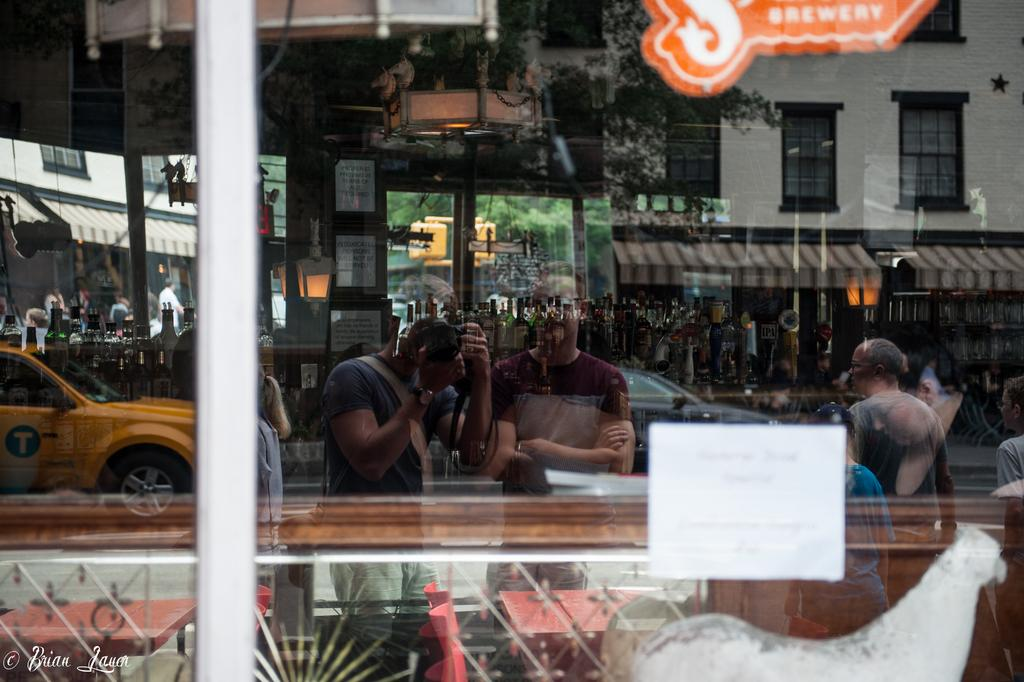What object is present in the image that has a glass component? The image contains a glass. What can be seen through the glass? Vehicles, persons, frames, trees, and buildings are visible through the glass. Can you tell me how many eggs the queen is holding in the image? There is no queen or eggs present in the image. Is there a rabbit visible through the glass in the image? There is no rabbit visible through the glass in the image. 